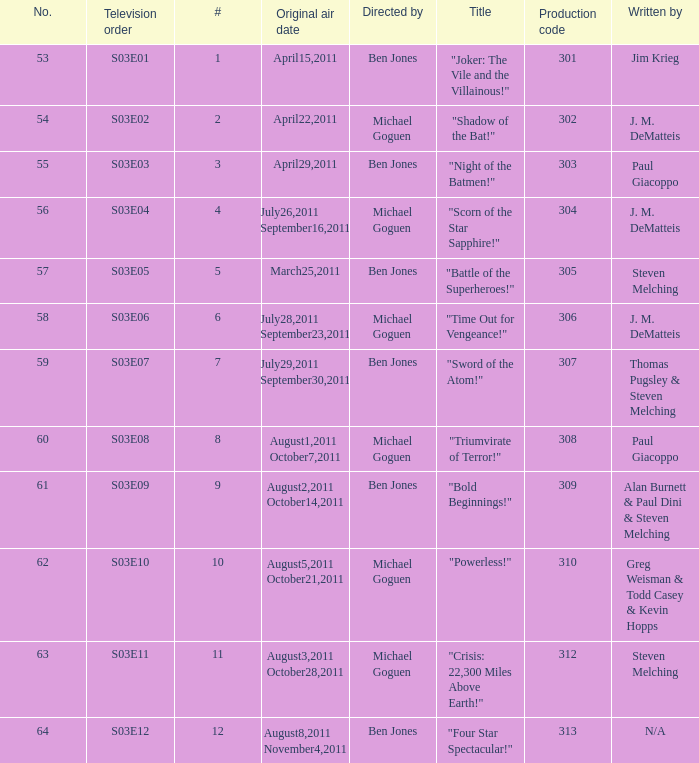What is the original air date of the episode directed by ben jones and written by steven melching?  March25,2011. Would you be able to parse every entry in this table? {'header': ['No.', 'Television order', '#', 'Original air date', 'Directed by', 'Title', 'Production code', 'Written by'], 'rows': [['53', 'S03E01', '1', 'April15,2011', 'Ben Jones', '"Joker: The Vile and the Villainous!"', '301', 'Jim Krieg'], ['54', 'S03E02', '2', 'April22,2011', 'Michael Goguen', '"Shadow of the Bat!"', '302', 'J. M. DeMatteis'], ['55', 'S03E03', '3', 'April29,2011', 'Ben Jones', '"Night of the Batmen!"', '303', 'Paul Giacoppo'], ['56', 'S03E04', '4', 'July26,2011 September16,2011', 'Michael Goguen', '"Scorn of the Star Sapphire!"', '304', 'J. M. DeMatteis'], ['57', 'S03E05', '5', 'March25,2011', 'Ben Jones', '"Battle of the Superheroes!"', '305', 'Steven Melching'], ['58', 'S03E06', '6', 'July28,2011 September23,2011', 'Michael Goguen', '"Time Out for Vengeance!"', '306', 'J. M. DeMatteis'], ['59', 'S03E07', '7', 'July29,2011 September30,2011', 'Ben Jones', '"Sword of the Atom!"', '307', 'Thomas Pugsley & Steven Melching'], ['60', 'S03E08', '8', 'August1,2011 October7,2011', 'Michael Goguen', '"Triumvirate of Terror!"', '308', 'Paul Giacoppo'], ['61', 'S03E09', '9', 'August2,2011 October14,2011', 'Ben Jones', '"Bold Beginnings!"', '309', 'Alan Burnett & Paul Dini & Steven Melching'], ['62', 'S03E10', '10', 'August5,2011 October21,2011', 'Michael Goguen', '"Powerless!"', '310', 'Greg Weisman & Todd Casey & Kevin Hopps'], ['63', 'S03E11', '11', 'August3,2011 October28,2011', 'Michael Goguen', '"Crisis: 22,300 Miles Above Earth!"', '312', 'Steven Melching'], ['64', 'S03E12', '12', 'August8,2011 November4,2011', 'Ben Jones', '"Four Star Spectacular!"', '313', 'N/A']]} 